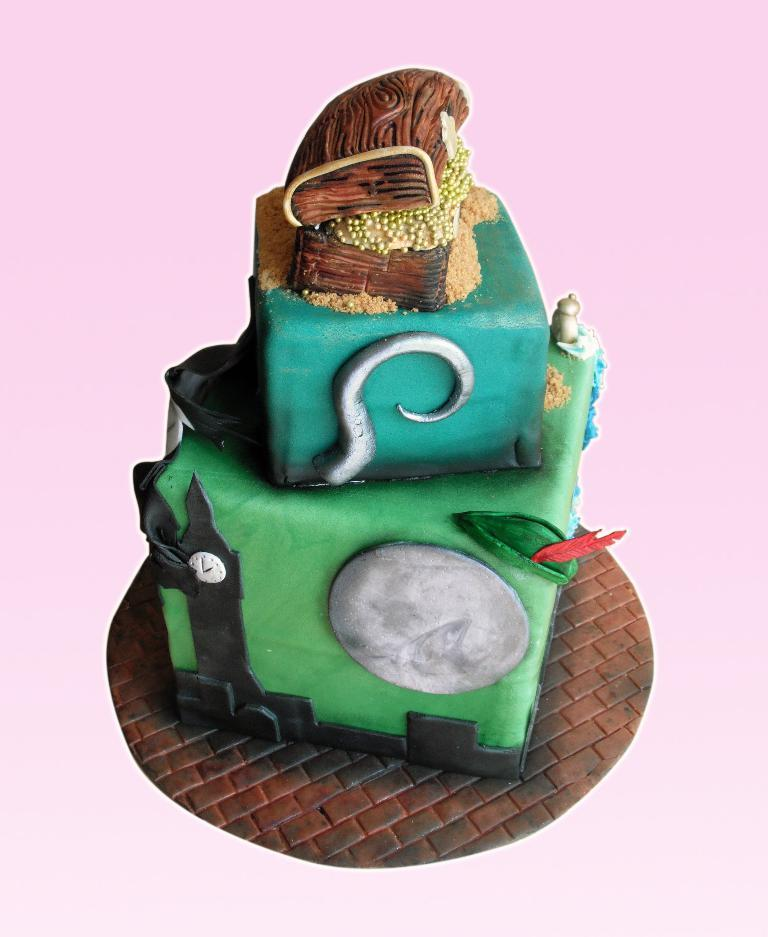What can be observed about the image's appearance? The image is edited. What is the main subject of the image? There is a cake in the image. Who is the owner of the finger seen touching the cake in the image? There is no finger touching the cake in the image, as it is edited and does not show any hands or fingers. What type of trousers is the person wearing while cutting the cake in the image? There is no person cutting the cake in the image, as it only shows a cake and does not depict any individuals. 